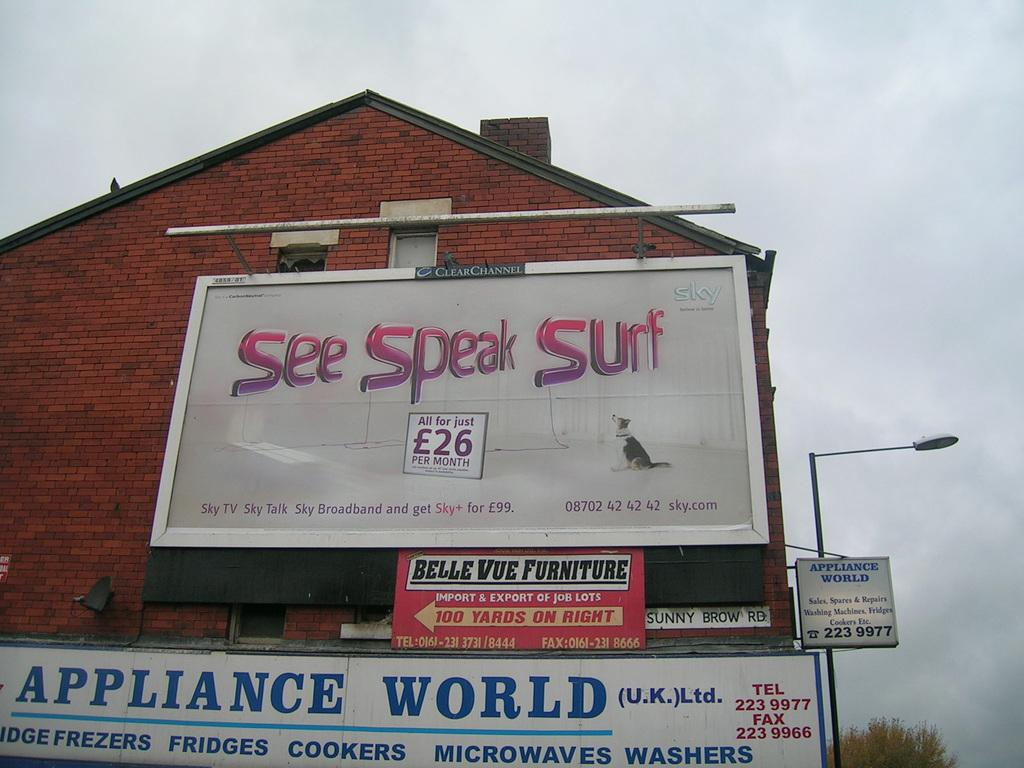<image>
Summarize the visual content of the image. A house with billboards on the side reading Speak Surf and Appliance World 